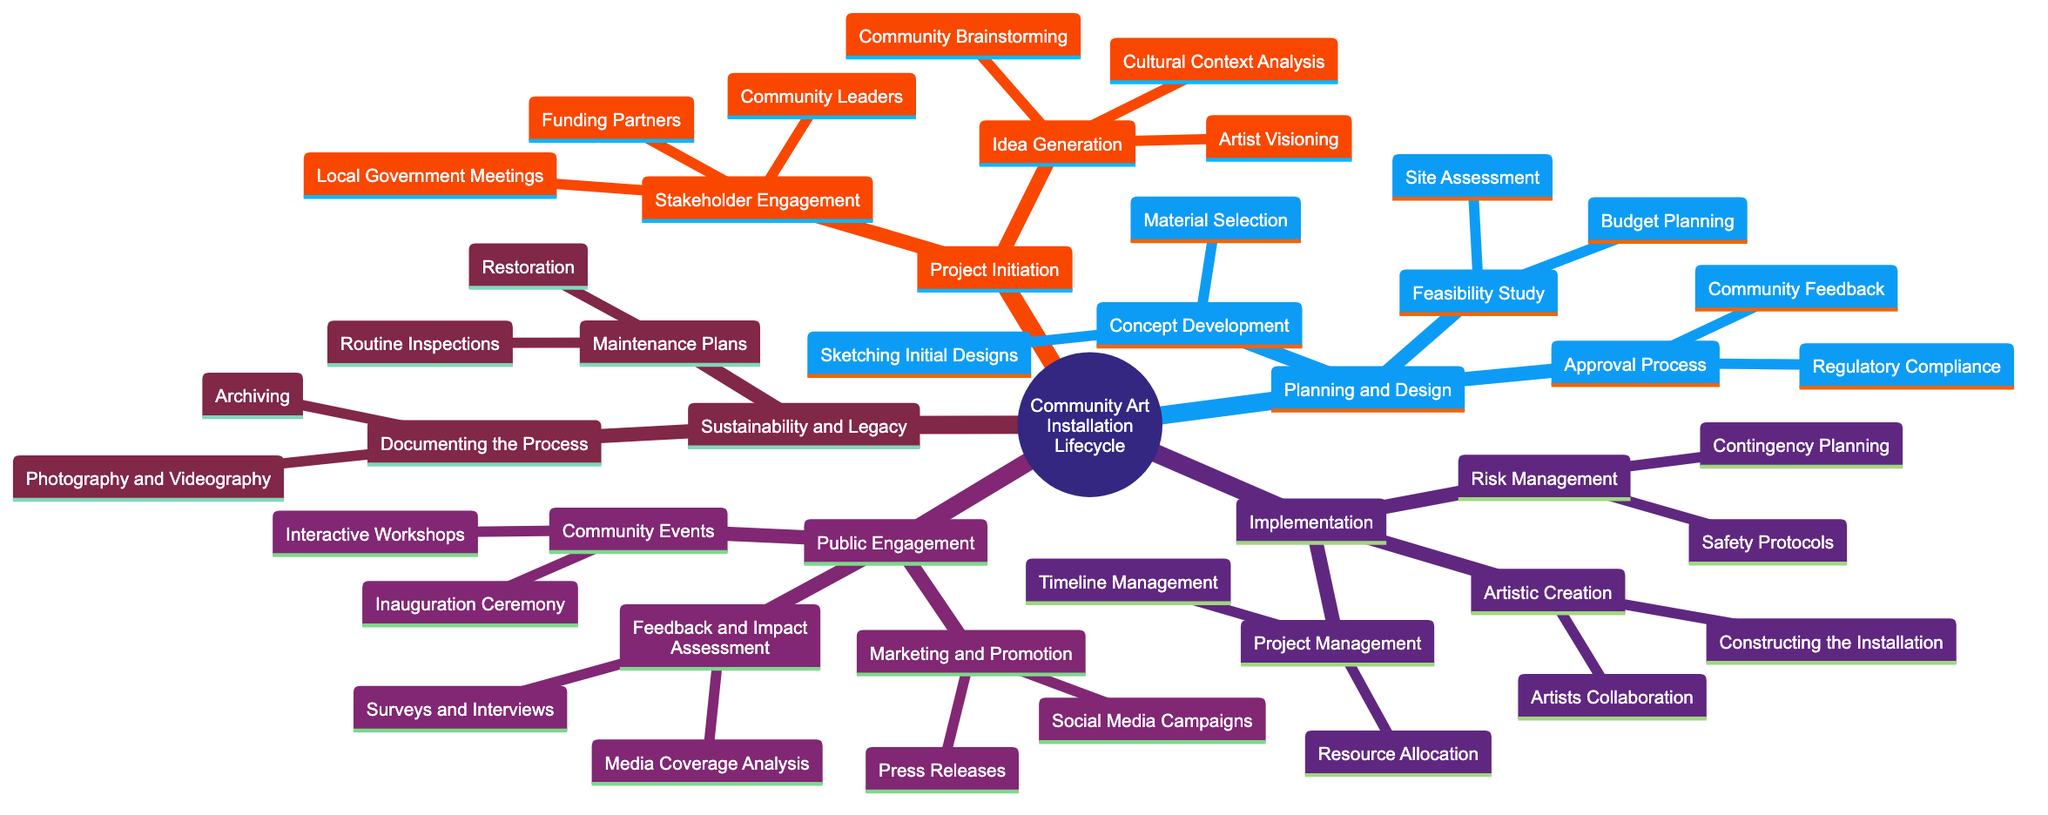What are the components of the Project Initiation phase? The Project Initiation phase includes two main components: Idea Generation and Stakeholder Engagement. Within these, specific activities such as Community Brainstorming and Local Government Meetings are detailed.
Answer: Idea Generation, Stakeholder Engagement How many elements are listed under Planning and Design? In the Planning and Design section, there are three main components: Concept Development, Feasibility Study, and Approval Process. Each of these components has several detailed activities, leading to a total of eight individual elements listed under this phase.
Answer: 8 What is one activity listed under Public Engagement? One activity listed under Public Engagement is "Inauguration Ceremony." This is part of a broader category that aims to engage the community with the art installation.
Answer: Inauguration Ceremony What is the relationship between Project Management and Risk Management? Project Management and Risk Management are both subcomponents of the Implementation phase, indicating that they work together in overseeing the installation process and ensuring safety measures are in place.
Answer: Both are subcomponents of Implementation Which phase includes "Routine Inspections"? The phase that includes "Routine Inspections" is Sustainability and Legacy. This indicates the ongoing maintenance plans necessary after the art installation is complete to ensure its longevity and care.
Answer: Sustainability and Legacy What are two forms of feedback in Feedback and Impact Assessment? Two forms of feedback in Feedback and Impact Assessment are "Surveys and Interviews" and "Media Coverage Analysis." These activities help assess the public's perception and the installation's impact on the community.
Answer: Surveys and Interviews, Media Coverage Analysis What is the last phase in the lifecycle of a community art installation? The last phase in the lifecycle is Sustainability and Legacy. This phase emphasizes the importance of maintaining the installation and documenting the process for future reference and impact.
Answer: Sustainability and Legacy How many activities are outlined in the Approval Process? The Approval Process includes two activities: "Regulatory Compliance" and "Community Feedback." This shows the steps required to ensure that the installation meets necessary regulations and community expectations.
Answer: 2 What is the overall structure of the concept map? The overall structure of the concept map is hierarchical, consisting of main phases that are subdivided into specific components and activities, illustrating the flow and connections throughout the lifecycle of community art installations.
Answer: Hierarchical structure 